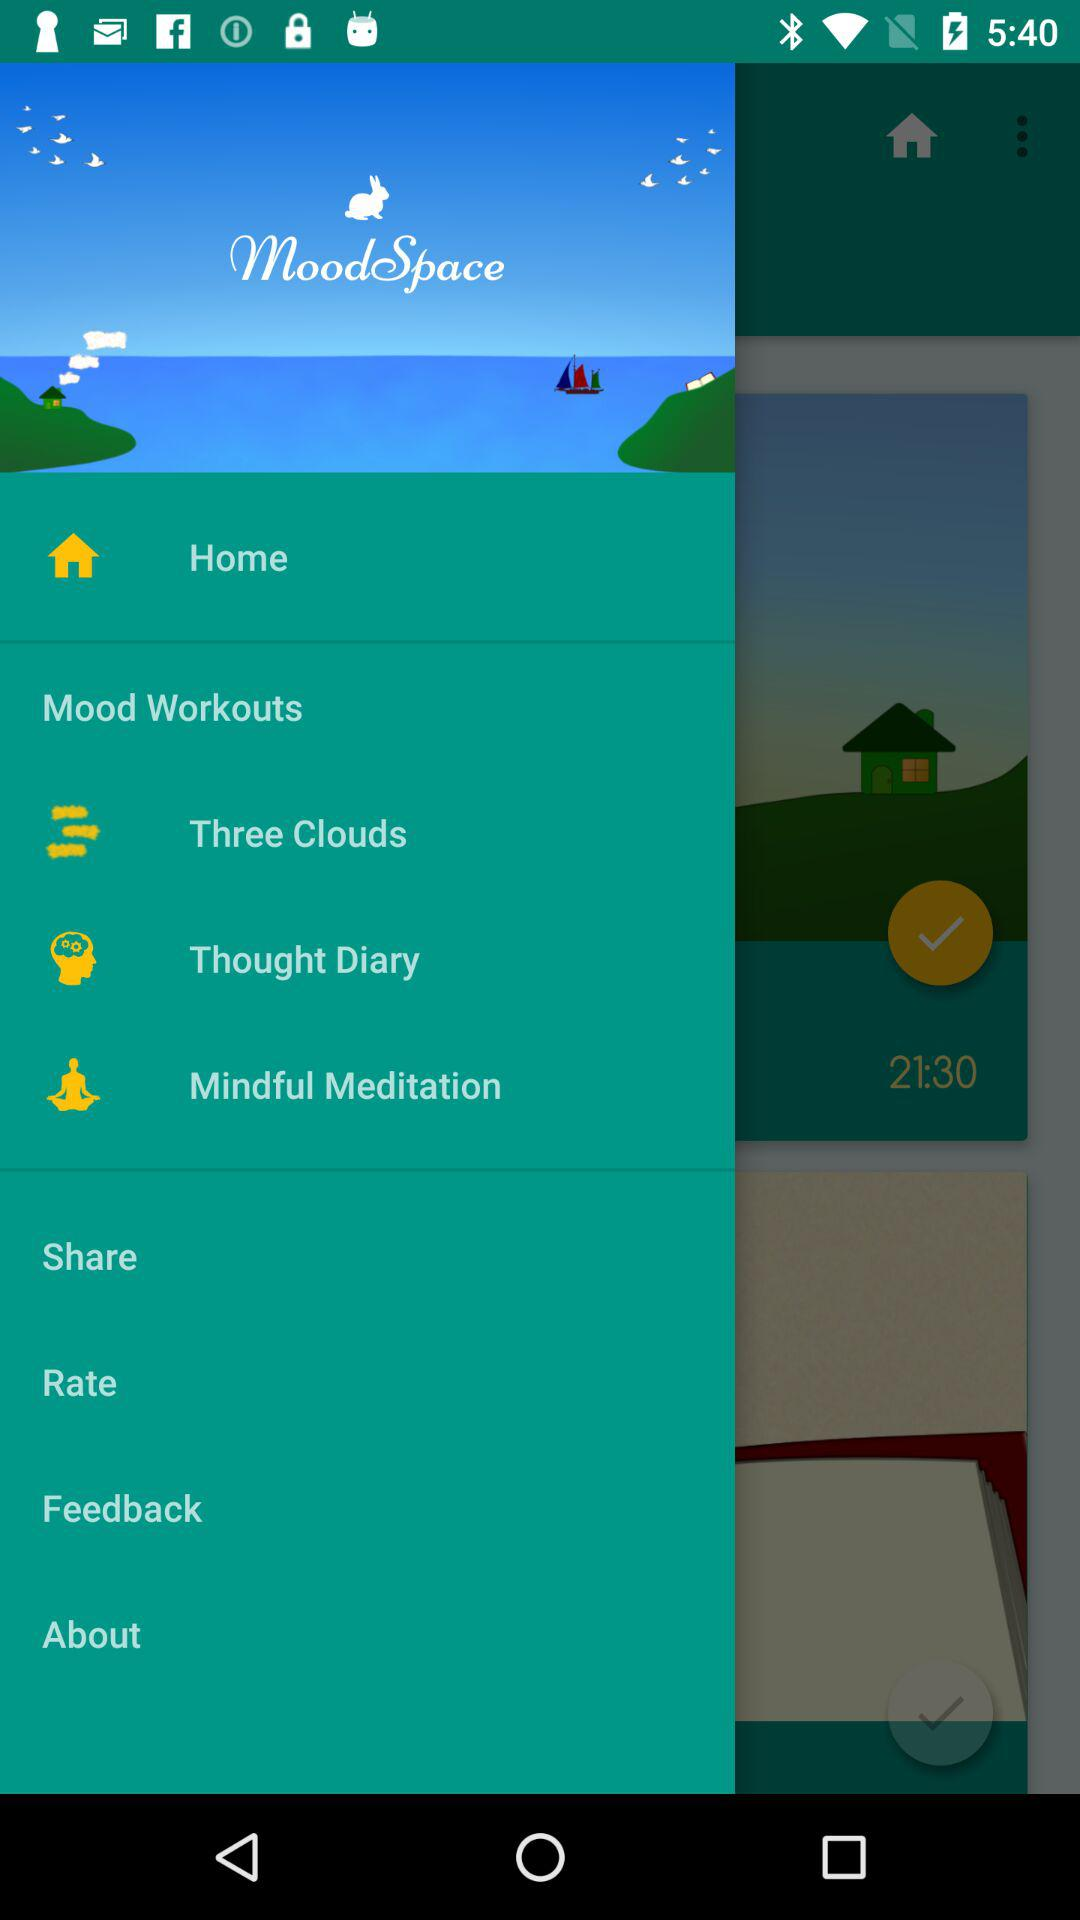What is the application name? The application name is "MoodSpace". 